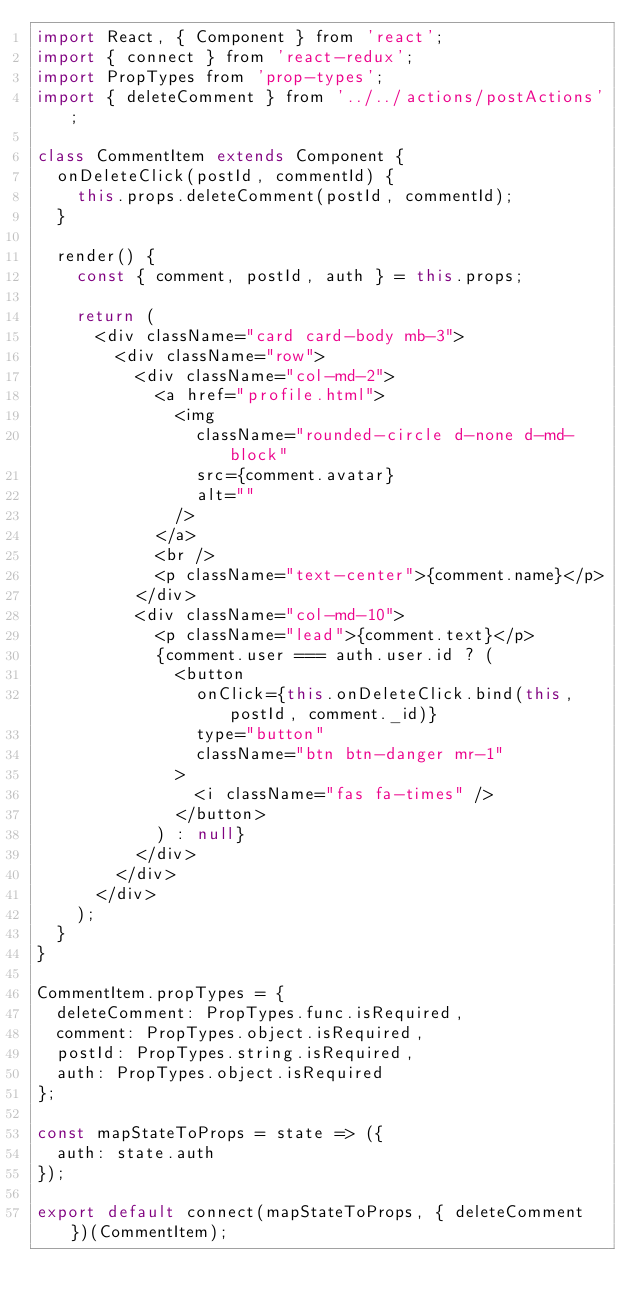Convert code to text. <code><loc_0><loc_0><loc_500><loc_500><_JavaScript_>import React, { Component } from 'react';
import { connect } from 'react-redux';
import PropTypes from 'prop-types';
import { deleteComment } from '../../actions/postActions';

class CommentItem extends Component {
  onDeleteClick(postId, commentId) {
    this.props.deleteComment(postId, commentId);
  }

  render() {
    const { comment, postId, auth } = this.props;

    return (
      <div className="card card-body mb-3">
        <div className="row">
          <div className="col-md-2">
            <a href="profile.html">
              <img
                className="rounded-circle d-none d-md-block"
                src={comment.avatar}
                alt=""
              />
            </a>
            <br />
            <p className="text-center">{comment.name}</p>
          </div>
          <div className="col-md-10">
            <p className="lead">{comment.text}</p>
            {comment.user === auth.user.id ? (
              <button
                onClick={this.onDeleteClick.bind(this, postId, comment._id)}
                type="button"
                className="btn btn-danger mr-1"
              >
                <i className="fas fa-times" />
              </button>
            ) : null}
          </div>
        </div>
      </div>
    );
  }
}

CommentItem.propTypes = {
  deleteComment: PropTypes.func.isRequired,
  comment: PropTypes.object.isRequired,
  postId: PropTypes.string.isRequired,
  auth: PropTypes.object.isRequired
};

const mapStateToProps = state => ({
  auth: state.auth
});

export default connect(mapStateToProps, { deleteComment })(CommentItem);
</code> 